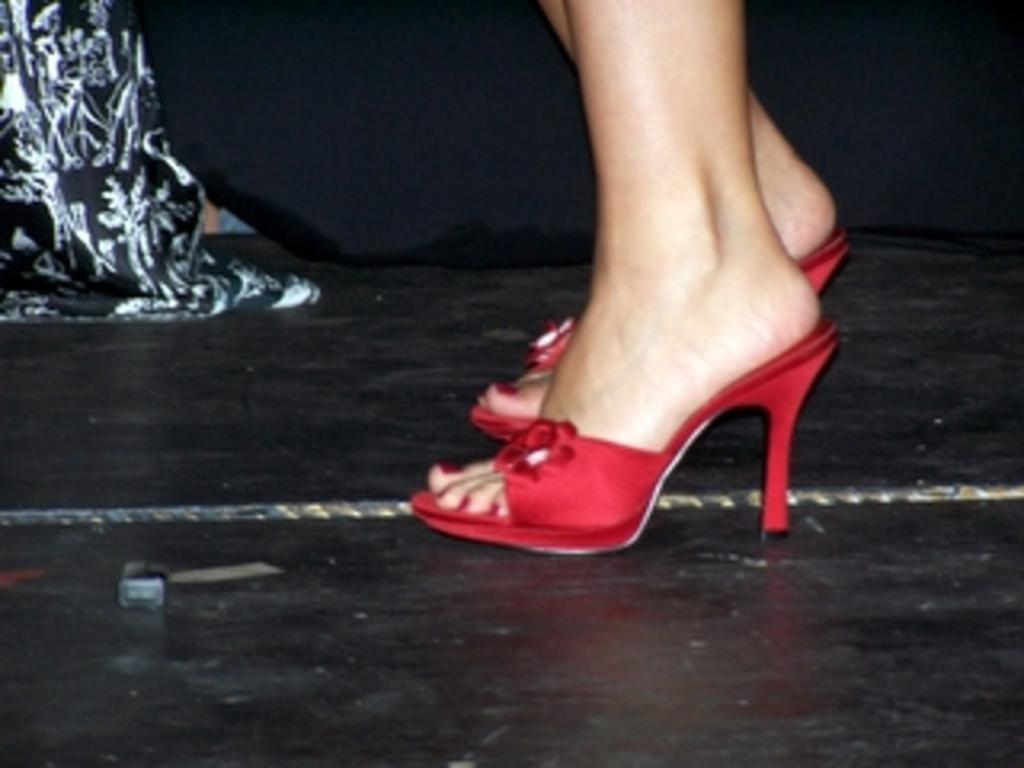What body parts are visible in the image? There are two legs visible in the image. What is covering the legs in the image? Footwear is present on the legs. What can be seen behind the legs in the image? There is cloth behind the legs. What type of fruit is sitting on the desk in the image? There is no desk or fruit present in the image. 